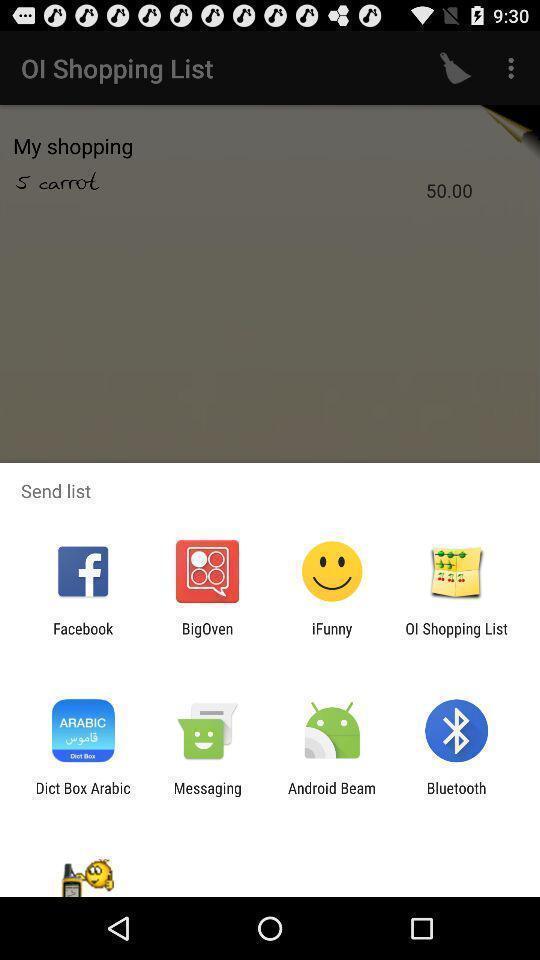Describe the key features of this screenshot. Pop-up showing the multiple share options. 